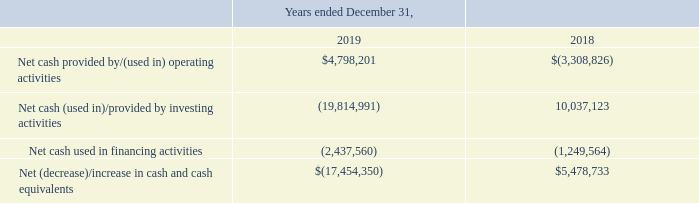Discussion of Cash Flows
During 2019, the $4.8 million of net cash provided by operating activities consisted of our net income of $5.3 million, and included non-cash charges for depreciation and amortization of $2.5 million, and stock-based compensation of $1.5 million, offset by a tax benefit from a partial release of the valuation allowances of $3.3 million and a net cash outflow of $1.8 million from changes in working capital. The changes in working capital were principally driven by an increase in accounts receivable of $2.2 million, an increase in inventory of $0.7 million, an increase in contract assets of $0.4 million, and an increase in other assets of $0.2 million, all partially offset by decreases in accounts payable and accrued expenses of $0.6 million and contract liabilities of $1.2 million,
In 2018, the $3.3 million of net cash used in operating activities consisted of our net income of $11.0 million and included a gain recognized on the sale of our optoelectronic segment that was sold in July 2018 of $8.6 million in addition to non-cash charges for depreciation and amortization of $1.2 million and stock-based compensation of $0.6 million, offset by a net cash outflow of $7.6 million from changes in working capital. The changes in working capital were principally driven by an increase in inventory of $1.0 million, and increase in accounts receivable of $6.2 million, and increase in contract assets of $0.8 million, and an increase in accounts payable and accrued liabilities of $0.5 million, all partially offset by a $1.8 million decrease in other assets.
Cash used in investing activities in 2019 consisted primarily of the $19.0 million payment for our acquisition of GP, $0.5 million of fixed asset additions and $0.3 million of capitalized intellectual property costs.
Cash provided by investing activities in 2018 consisted primarily of the proceeds from the sale of our optoelectronic segment of $15.8 million, partially offset by the $5.0 million payment for our acquisition of MOI, $0.4 million of fixed asset additions and $0.4 million of capitalized intellectual property rights.
Cash used in financing activities for the year ended December 31, 2019 was $2.4 million, compared to $1.2 million in 2018. During 2019, we repaid $0.6 million on our term loans with SVB and used $2.2 million to repurchase our common stock under our stock repurchase program. These payments were partially offset by $0.4 million received from exercises of stock options and warrants. During 2018, we repaid $1.8 million on our outstanding term loan with SVB and used $0.5 million to repurchase our common stock under our stock repurchase program. These payments were partially offset by $1.1 million received from exercises of stock options and warrants.
How much outstanding term loan with SVB was repaid during 2018?  $1.8 million. What is the change in Net cash provided by/(used in) operating activities from December 31, 2018 and 2019? 4,798,201-(3,308,826)
Answer: 8107027. What is the average Net cash provided by/(used in) operating activities for December 31, 2018 and 2019? (4,798,201+(3,308,826)) / 2
Answer: 744687.5. In which year was Net cash provided by/(used in) operating activities negative? Locate and analyze net cash provided by/(used in) operating activities in row 3
answer: 2018. What was the Net cash provided by/(used in) operating activities in 2019 and 2018? $4,798,201, $(3,308,826). What was the net increase in cash and cash equivalents in 2018? $5,478,733. 